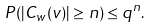<formula> <loc_0><loc_0><loc_500><loc_500>P ( | C _ { w } ( v ) | \geq n ) \leq q ^ { n } .</formula> 